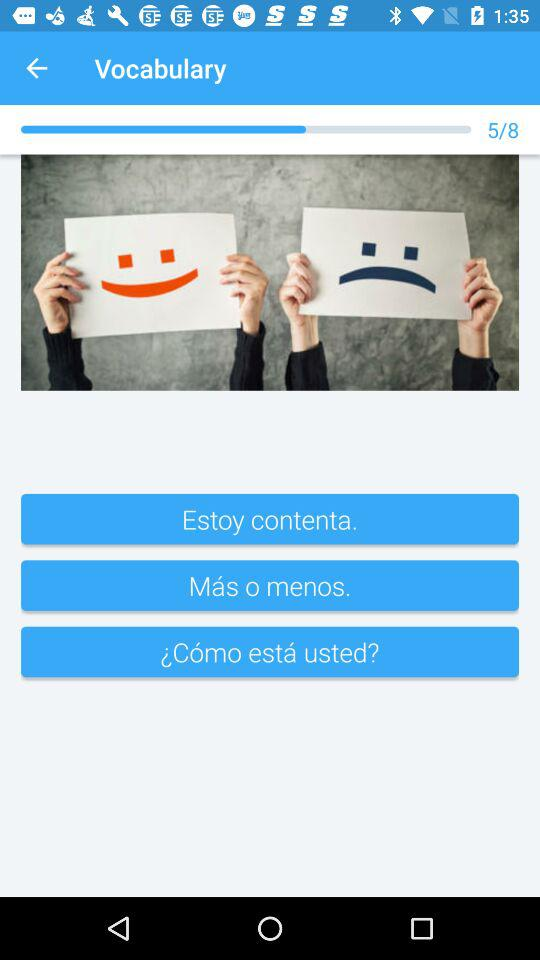How many images in total are there? There are 8 images in total. 